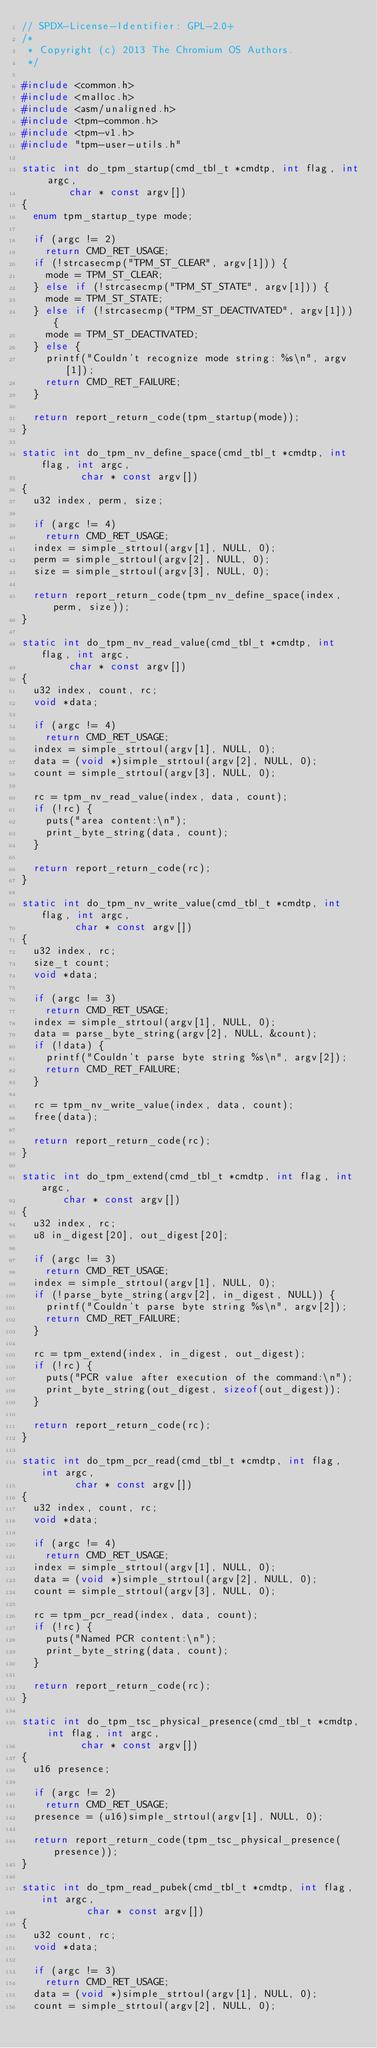Convert code to text. <code><loc_0><loc_0><loc_500><loc_500><_C_>// SPDX-License-Identifier: GPL-2.0+
/*
 * Copyright (c) 2013 The Chromium OS Authors.
 */

#include <common.h>
#include <malloc.h>
#include <asm/unaligned.h>
#include <tpm-common.h>
#include <tpm-v1.h>
#include "tpm-user-utils.h"

static int do_tpm_startup(cmd_tbl_t *cmdtp, int flag, int argc,
			  char * const argv[])
{
	enum tpm_startup_type mode;

	if (argc != 2)
		return CMD_RET_USAGE;
	if (!strcasecmp("TPM_ST_CLEAR", argv[1])) {
		mode = TPM_ST_CLEAR;
	} else if (!strcasecmp("TPM_ST_STATE", argv[1])) {
		mode = TPM_ST_STATE;
	} else if (!strcasecmp("TPM_ST_DEACTIVATED", argv[1])) {
		mode = TPM_ST_DEACTIVATED;
	} else {
		printf("Couldn't recognize mode string: %s\n", argv[1]);
		return CMD_RET_FAILURE;
	}

	return report_return_code(tpm_startup(mode));
}

static int do_tpm_nv_define_space(cmd_tbl_t *cmdtp, int flag, int argc,
				  char * const argv[])
{
	u32 index, perm, size;

	if (argc != 4)
		return CMD_RET_USAGE;
	index = simple_strtoul(argv[1], NULL, 0);
	perm = simple_strtoul(argv[2], NULL, 0);
	size = simple_strtoul(argv[3], NULL, 0);

	return report_return_code(tpm_nv_define_space(index, perm, size));
}

static int do_tpm_nv_read_value(cmd_tbl_t *cmdtp, int flag, int argc,
				char * const argv[])
{
	u32 index, count, rc;
	void *data;

	if (argc != 4)
		return CMD_RET_USAGE;
	index = simple_strtoul(argv[1], NULL, 0);
	data = (void *)simple_strtoul(argv[2], NULL, 0);
	count = simple_strtoul(argv[3], NULL, 0);

	rc = tpm_nv_read_value(index, data, count);
	if (!rc) {
		puts("area content:\n");
		print_byte_string(data, count);
	}

	return report_return_code(rc);
}

static int do_tpm_nv_write_value(cmd_tbl_t *cmdtp, int flag, int argc,
				 char * const argv[])
{
	u32 index, rc;
	size_t count;
	void *data;

	if (argc != 3)
		return CMD_RET_USAGE;
	index = simple_strtoul(argv[1], NULL, 0);
	data = parse_byte_string(argv[2], NULL, &count);
	if (!data) {
		printf("Couldn't parse byte string %s\n", argv[2]);
		return CMD_RET_FAILURE;
	}

	rc = tpm_nv_write_value(index, data, count);
	free(data);

	return report_return_code(rc);
}

static int do_tpm_extend(cmd_tbl_t *cmdtp, int flag, int argc,
			 char * const argv[])
{
	u32 index, rc;
	u8 in_digest[20], out_digest[20];

	if (argc != 3)
		return CMD_RET_USAGE;
	index = simple_strtoul(argv[1], NULL, 0);
	if (!parse_byte_string(argv[2], in_digest, NULL)) {
		printf("Couldn't parse byte string %s\n", argv[2]);
		return CMD_RET_FAILURE;
	}

	rc = tpm_extend(index, in_digest, out_digest);
	if (!rc) {
		puts("PCR value after execution of the command:\n");
		print_byte_string(out_digest, sizeof(out_digest));
	}

	return report_return_code(rc);
}

static int do_tpm_pcr_read(cmd_tbl_t *cmdtp, int flag, int argc,
			   char * const argv[])
{
	u32 index, count, rc;
	void *data;

	if (argc != 4)
		return CMD_RET_USAGE;
	index = simple_strtoul(argv[1], NULL, 0);
	data = (void *)simple_strtoul(argv[2], NULL, 0);
	count = simple_strtoul(argv[3], NULL, 0);

	rc = tpm_pcr_read(index, data, count);
	if (!rc) {
		puts("Named PCR content:\n");
		print_byte_string(data, count);
	}

	return report_return_code(rc);
}

static int do_tpm_tsc_physical_presence(cmd_tbl_t *cmdtp, int flag, int argc,
					char * const argv[])
{
	u16 presence;

	if (argc != 2)
		return CMD_RET_USAGE;
	presence = (u16)simple_strtoul(argv[1], NULL, 0);

	return report_return_code(tpm_tsc_physical_presence(presence));
}

static int do_tpm_read_pubek(cmd_tbl_t *cmdtp, int flag, int argc,
			     char * const argv[])
{
	u32 count, rc;
	void *data;

	if (argc != 3)
		return CMD_RET_USAGE;
	data = (void *)simple_strtoul(argv[1], NULL, 0);
	count = simple_strtoul(argv[2], NULL, 0);
</code> 